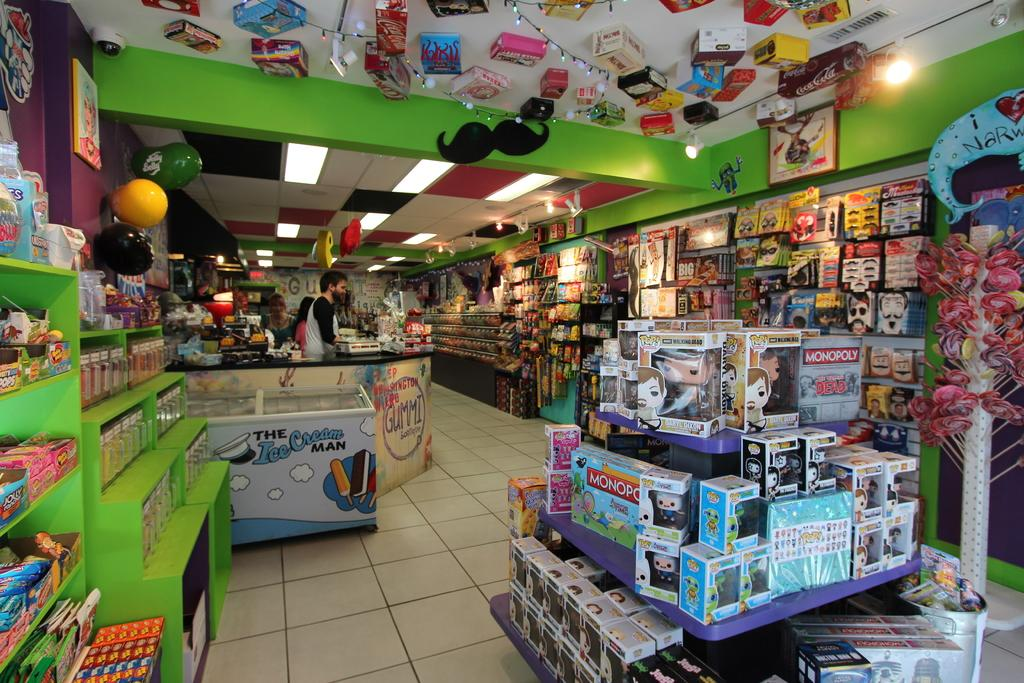<image>
Share a concise interpretation of the image provided. A fun, colorful store displaying board games such as Monopoly, POP! Walking Dead figurines, The Ice Cream Man sweets and Jelly Belly candies. 